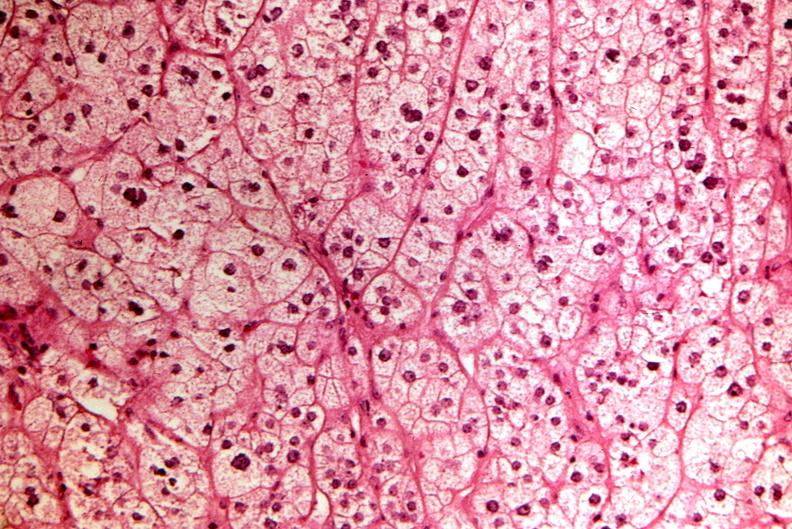s carcinoma metastatic lung present?
Answer the question using a single word or phrase. No 